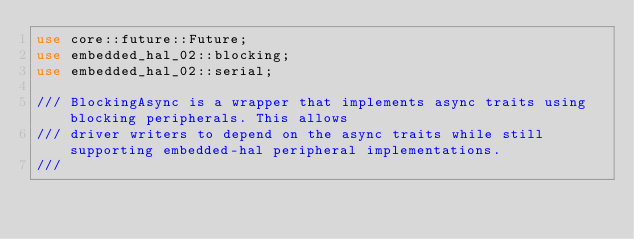<code> <loc_0><loc_0><loc_500><loc_500><_Rust_>use core::future::Future;
use embedded_hal_02::blocking;
use embedded_hal_02::serial;

/// BlockingAsync is a wrapper that implements async traits using blocking peripherals. This allows
/// driver writers to depend on the async traits while still supporting embedded-hal peripheral implementations.
///</code> 